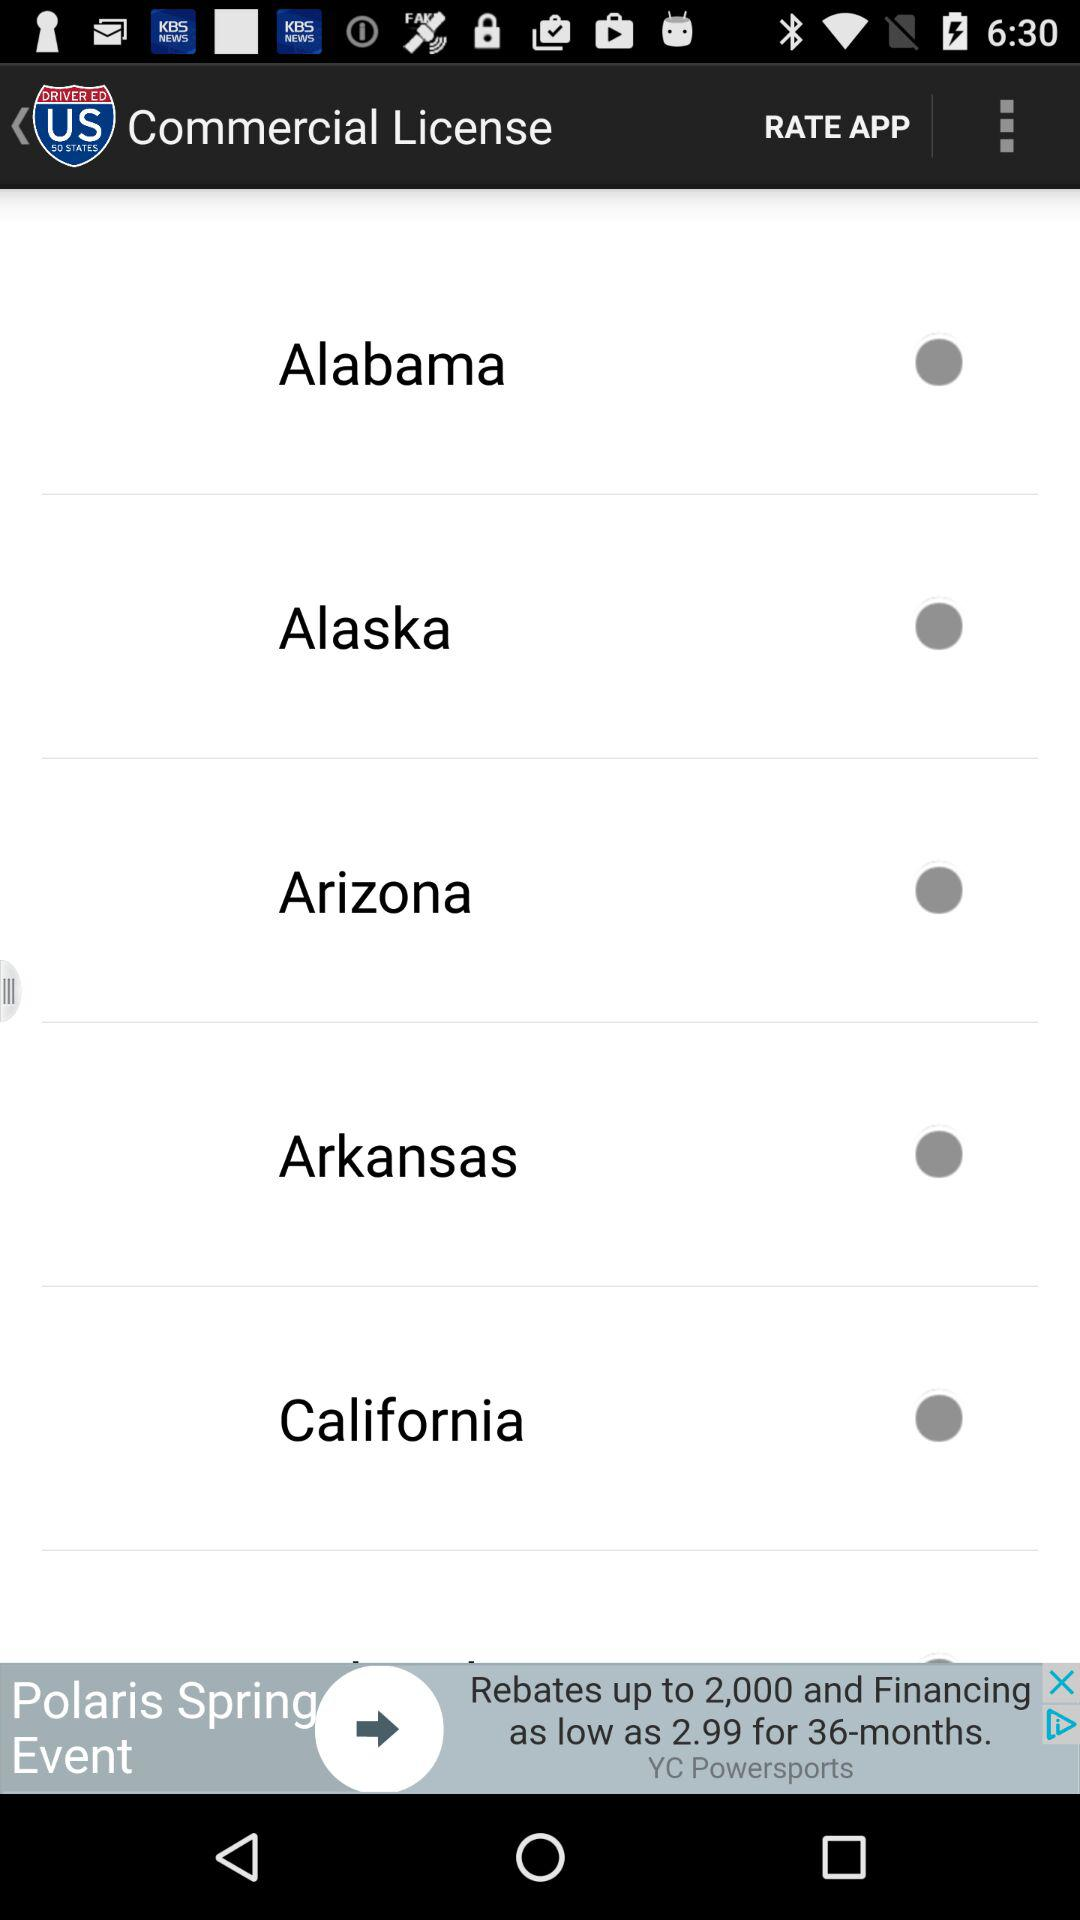What is the status of "Alaska"? The status is "off". 